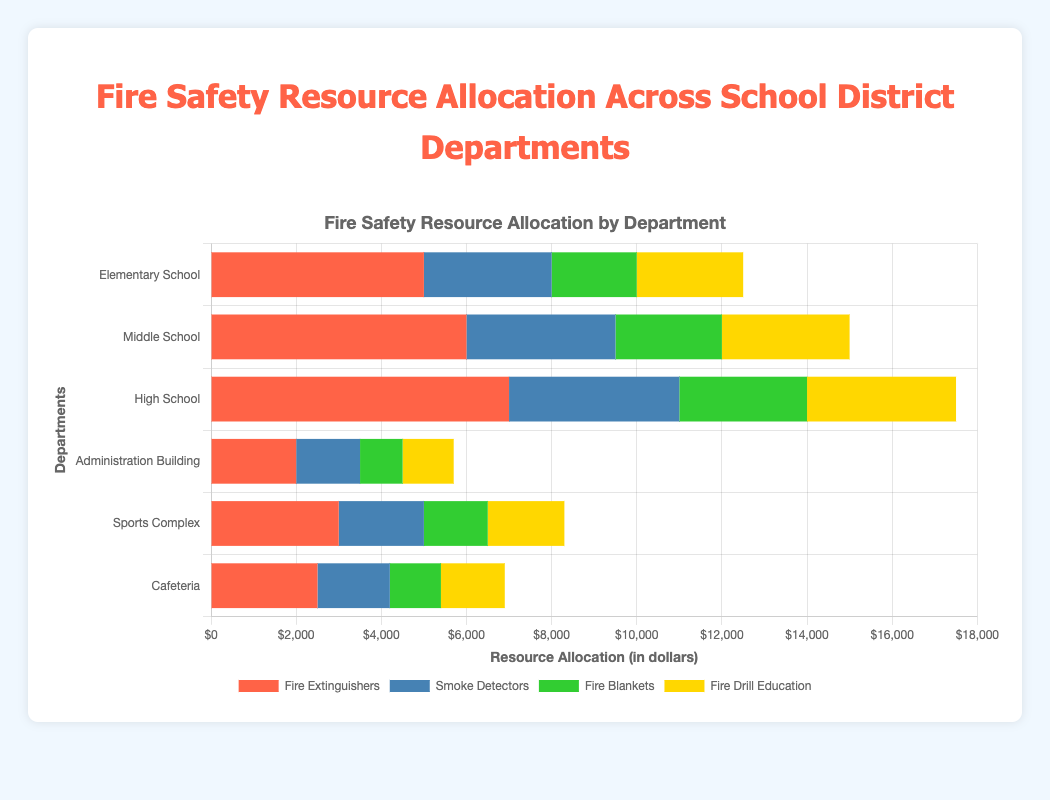Who has allocated the most resources to fire extinguishers? Look for the longest red bar in the chart. The High School department has the longest red bar, indicating it has allocated the most resources to fire extinguishers.
Answer: High School Which department has spent the least on smoke detectors? Look for the shortest blue bar in the chart. The Administration Building has the shortest blue bar, indicating it has spent the least on smoke detectors.
Answer: Administration Building What is the total amount spent on fire drill education by the Elementary School and the Middle School combined? Identify the lengths of the yellow bars for both Elementary School and Middle School, then sum these values: 2500 + 3000 = 5500.
Answer: 5500 Which department has the highest combined allocation for fire blankets and fire drill education? Calculate the combined length of green and yellow bars for each department. High School has 3000 (fire blankets) + 3500 (fire drill education) = 6500, which is the highest.
Answer: High School What is the difference between the resources allocated to fire blankets by the High School and the Sports Complex? Subtract the length of the green bar for Sports Complex from that of the High School: 3000 - 1500 = 1500.
Answer: 1500 Which has a greater allocation: smoke detectors in the Cafeteria or fire drill education in the Sports Complex? Compare the lengths of the blue bar (smoke detectors) for Cafeteria and the yellow bar (fire drill education) for Sports Complex. Smoke detectors in Cafeteria is 1700, and fire drill education in Sports Complex is 1800. 1800 is greater than 1700.
Answer: Fire drill education in the Sports Complex What is the total amount allocated to fire extinguishers across all departments? Sum the lengths of all red bars: 5000 (Elementary School) + 6000 (Middle School) + 7000 (High School) + 2000 (Administration Building) + 3000 (Sports Complex) + 2500 (Cafeteria) = 25500.
Answer: 25500 